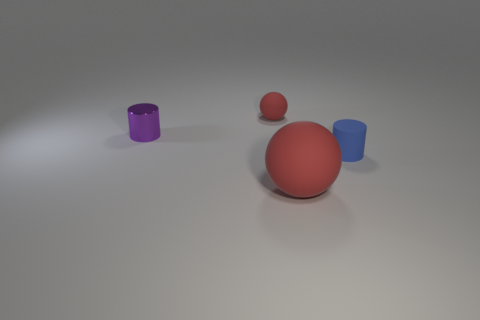Is there any other thing that is made of the same material as the small purple object?
Keep it short and to the point. No. There is another metal thing that is the same shape as the blue thing; what size is it?
Offer a very short reply. Small. The tiny matte object to the right of the big thing has what shape?
Offer a terse response. Cylinder. Do the small cylinder that is to the right of the large matte thing and the red sphere behind the big object have the same material?
Ensure brevity in your answer.  Yes. The big red object is what shape?
Ensure brevity in your answer.  Sphere. Is the number of metal cylinders to the right of the small red object the same as the number of tiny cyan cylinders?
Make the answer very short. Yes. What is the size of the thing that is the same color as the tiny rubber ball?
Offer a very short reply. Large. Are there any tiny red spheres made of the same material as the purple cylinder?
Provide a succinct answer. No. Does the tiny blue matte object in front of the metal cylinder have the same shape as the small matte object on the left side of the rubber cylinder?
Give a very brief answer. No. Are there any green shiny cubes?
Provide a short and direct response. No. 